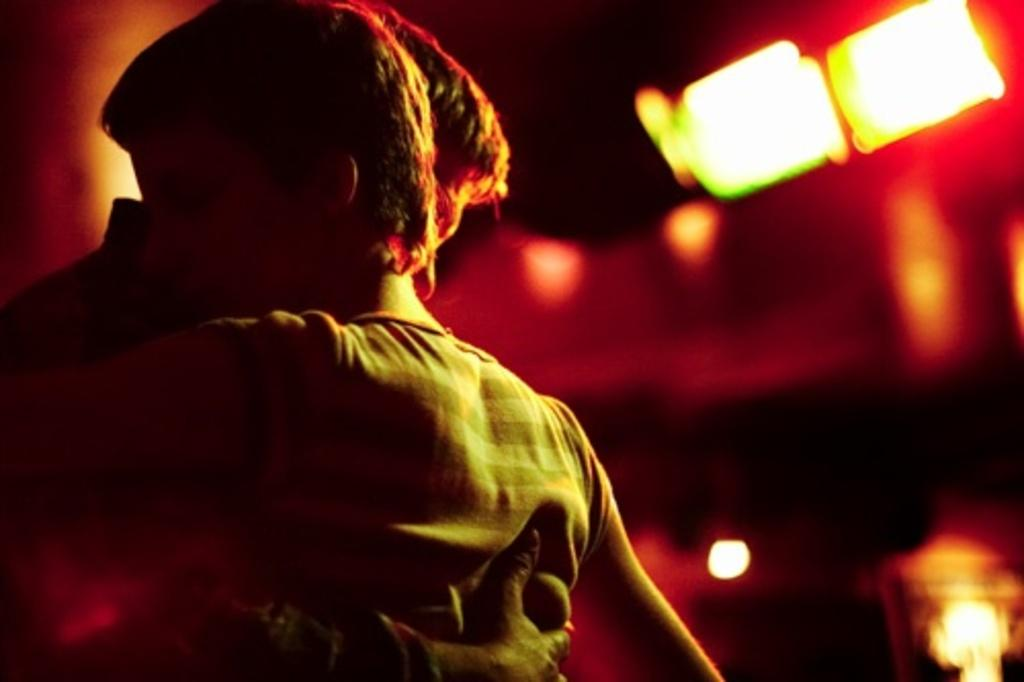How many people are in the image? There are two persons in the image. What are the two persons doing in the image? The two persons are hugging each other. What can be seen in the background of the image? There are lights in the background of the image. What type of egg is being used to sew a thread in the image? There is no egg or thread present in the image; it features two persons hugging each other. 